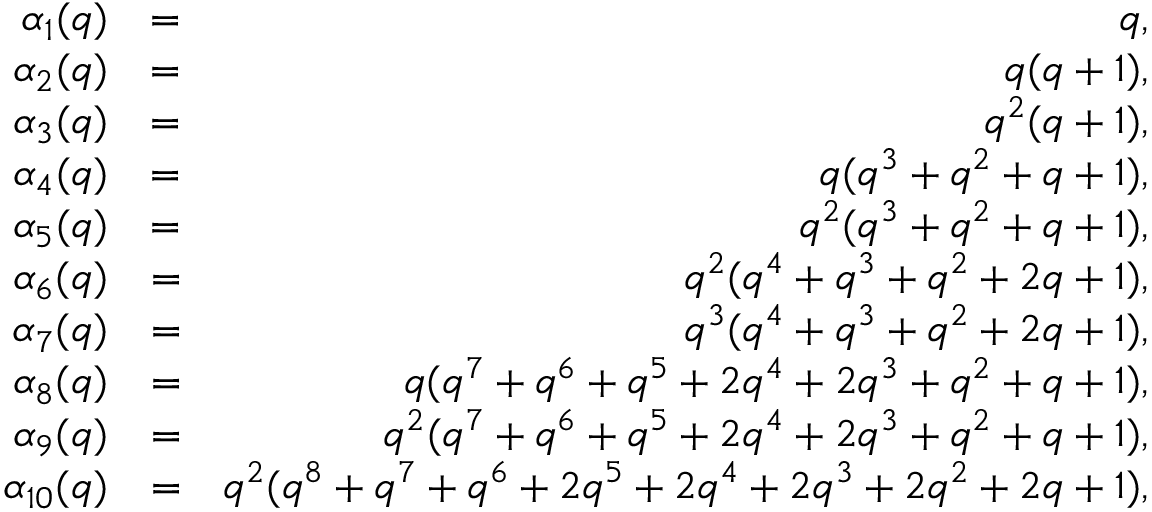Convert formula to latex. <formula><loc_0><loc_0><loc_500><loc_500>\begin{array} { r l r } { \alpha _ { 1 } ( q ) } & { = } & { q , } \\ { \alpha _ { 2 } ( q ) } & { = } & { q ( q + 1 ) , } \\ { \alpha _ { 3 } ( q ) } & { = } & { q ^ { 2 } ( q + 1 ) , } \\ { \alpha _ { 4 } ( q ) } & { = } & { q ( q ^ { 3 } + q ^ { 2 } + q + 1 ) , } \\ { \alpha _ { 5 } ( q ) } & { = } & { q ^ { 2 } ( q ^ { 3 } + q ^ { 2 } + q + 1 ) , } \\ { \alpha _ { 6 } ( q ) } & { = } & { q ^ { 2 } ( q ^ { 4 } + q ^ { 3 } + q ^ { 2 } + 2 q + 1 ) , } \\ { \alpha _ { 7 } ( q ) } & { = } & { q ^ { 3 } ( q ^ { 4 } + q ^ { 3 } + q ^ { 2 } + 2 q + 1 ) , } \\ { \alpha _ { 8 } ( q ) } & { = } & { q ( q ^ { 7 } + q ^ { 6 } + q ^ { 5 } + 2 q ^ { 4 } + 2 q ^ { 3 } + q ^ { 2 } + q + 1 ) , } \\ { \alpha _ { 9 } ( q ) } & { = } & { q ^ { 2 } ( q ^ { 7 } + q ^ { 6 } + q ^ { 5 } + 2 q ^ { 4 } + 2 q ^ { 3 } + q ^ { 2 } + q + 1 ) , } \\ { \alpha _ { 1 0 } ( q ) } & { = } & { q ^ { 2 } ( q ^ { 8 } + q ^ { 7 } + q ^ { 6 } + 2 q ^ { 5 } + 2 q ^ { 4 } + 2 q ^ { 3 } + 2 q ^ { 2 } + 2 q + 1 ) , } \end{array}</formula> 